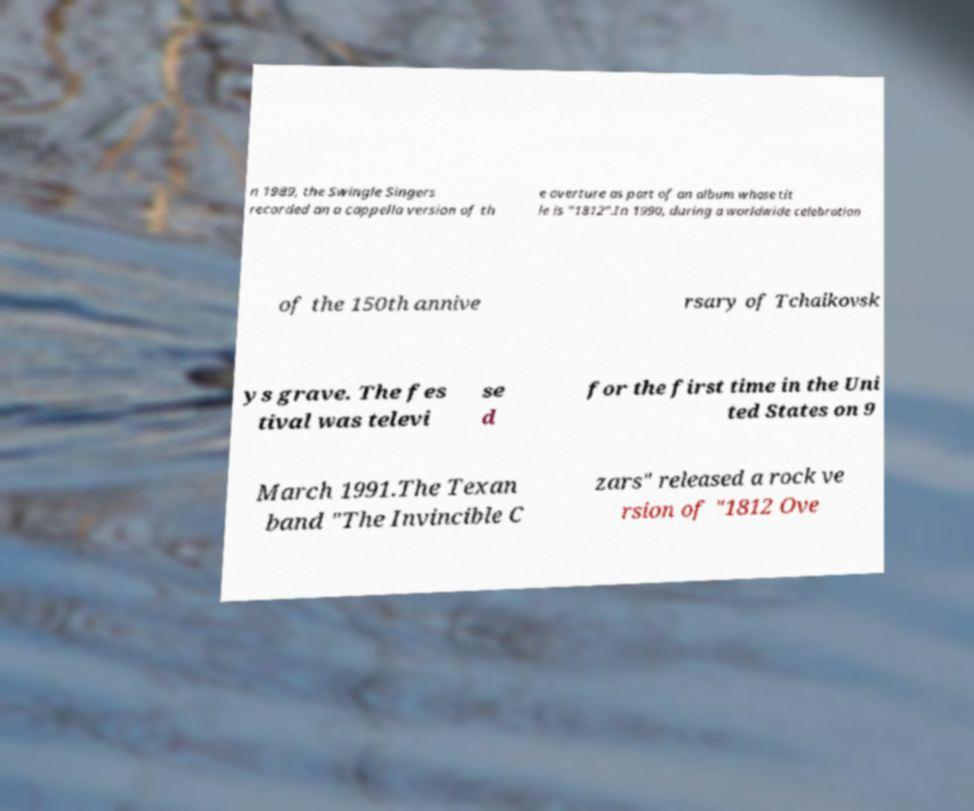Please identify and transcribe the text found in this image. n 1989, the Swingle Singers recorded an a cappella version of th e overture as part of an album whose tit le is "1812".In 1990, during a worldwide celebration of the 150th annive rsary of Tchaikovsk ys grave. The fes tival was televi se d for the first time in the Uni ted States on 9 March 1991.The Texan band "The Invincible C zars" released a rock ve rsion of "1812 Ove 